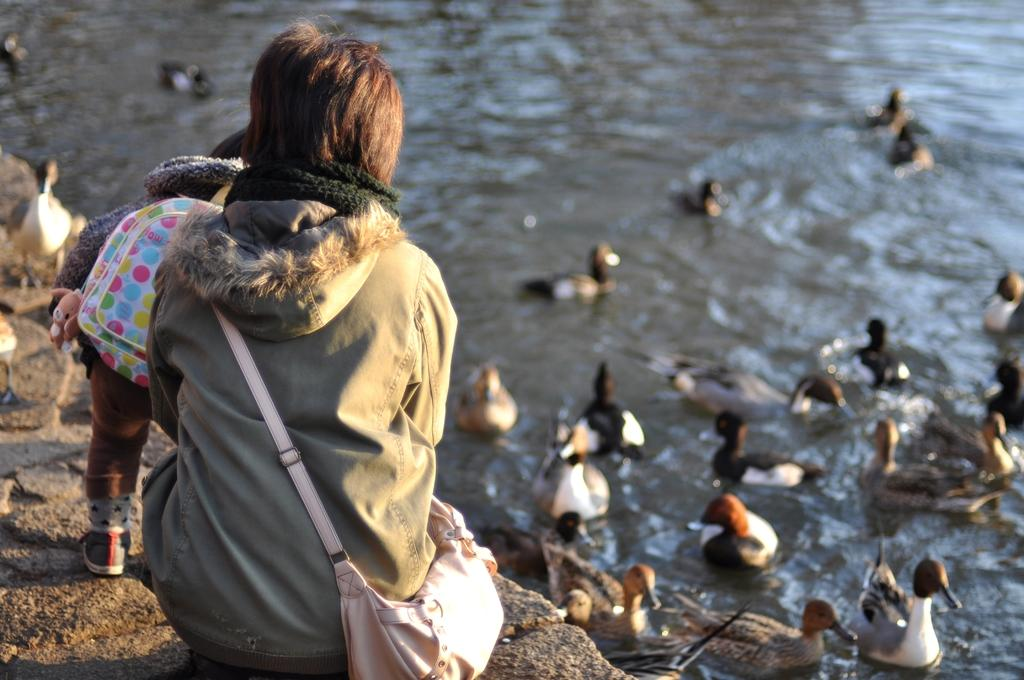What is the main subject of the image? There is a kid in the image. Can you identify any other people in the image? Yes, there is a person in the image. What animals are present in the image? There are two ducks on a rock and ducks in the water in the background of the image. How many yaks are visible in the image? There are no yaks present in the image. Who is the owner of the ducks in the image? The image does not provide information about the ownership of the ducks. 